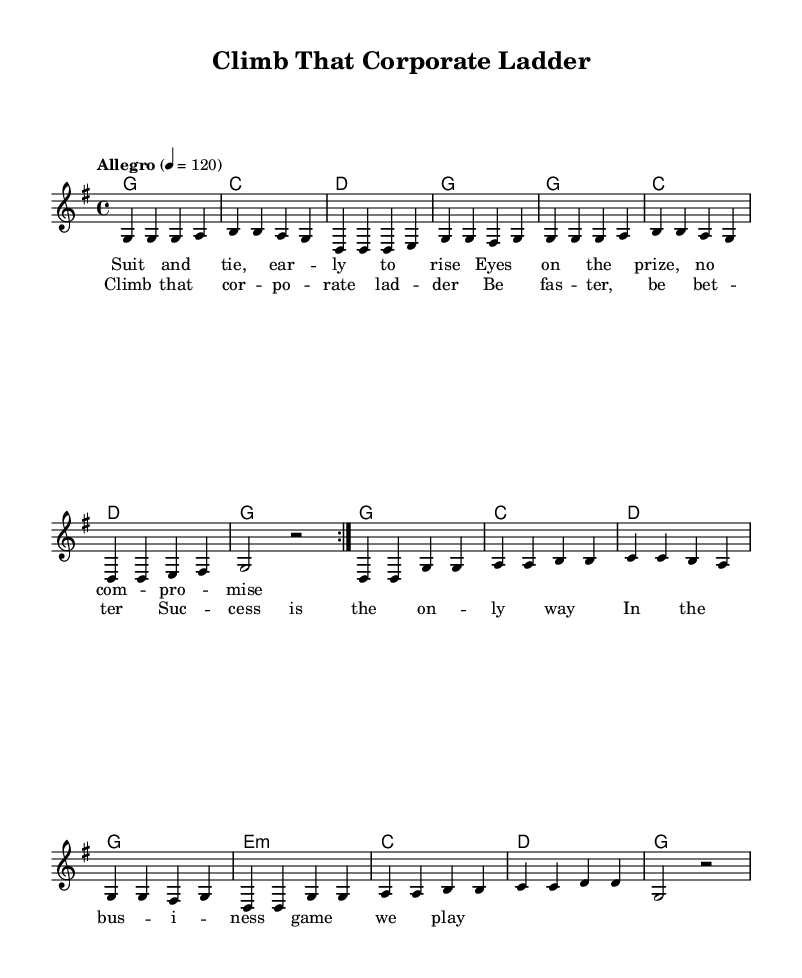What is the key signature of this music? The key signature is G major, which has one sharp.
Answer: G major What is the time signature of this music? The time signature is 4/4, indicating four beats per measure.
Answer: 4/4 What is the tempo marking in this music? The tempo marking is "Allegro," indicating a fast pace.
Answer: Allegro How many measures are repeated in the melody? The melody has two measures repeated with the first volta.
Answer: Two What is the main theme of the lyrics? The main theme focuses on ambition and success in a corporate setting.
Answer: Ambition and success What chords are used in the chorus? The chords used in the chorus are G, C, and D.
Answer: G, C, D What kind of instruments would typically play this type of music? Typical instruments include guitar, banjo, and fiddle.
Answer: Guitar, banjo, fiddle 